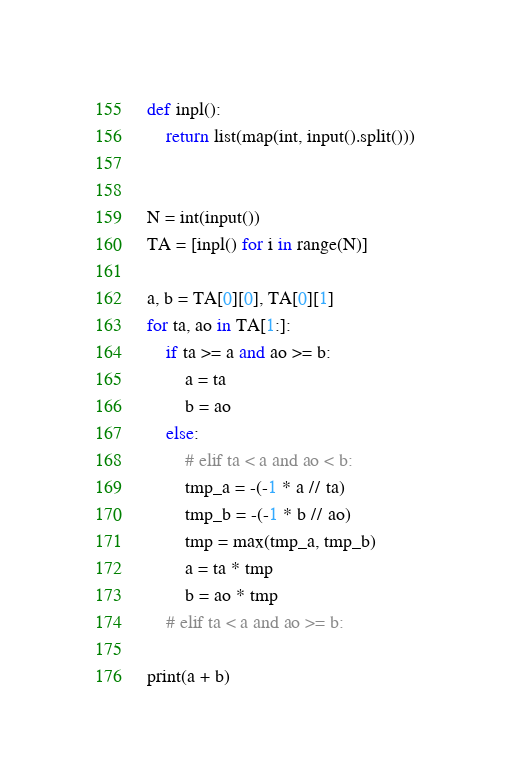<code> <loc_0><loc_0><loc_500><loc_500><_Python_>def inpl():
    return list(map(int, input().split()))


N = int(input())
TA = [inpl() for i in range(N)]

a, b = TA[0][0], TA[0][1]
for ta, ao in TA[1:]:
    if ta >= a and ao >= b:
        a = ta
        b = ao
    else:
        # elif ta < a and ao < b:
        tmp_a = -(-1 * a // ta)
        tmp_b = -(-1 * b // ao)
        tmp = max(tmp_a, tmp_b)
        a = ta * tmp
        b = ao * tmp
    # elif ta < a and ao >= b:

print(a + b)
</code> 